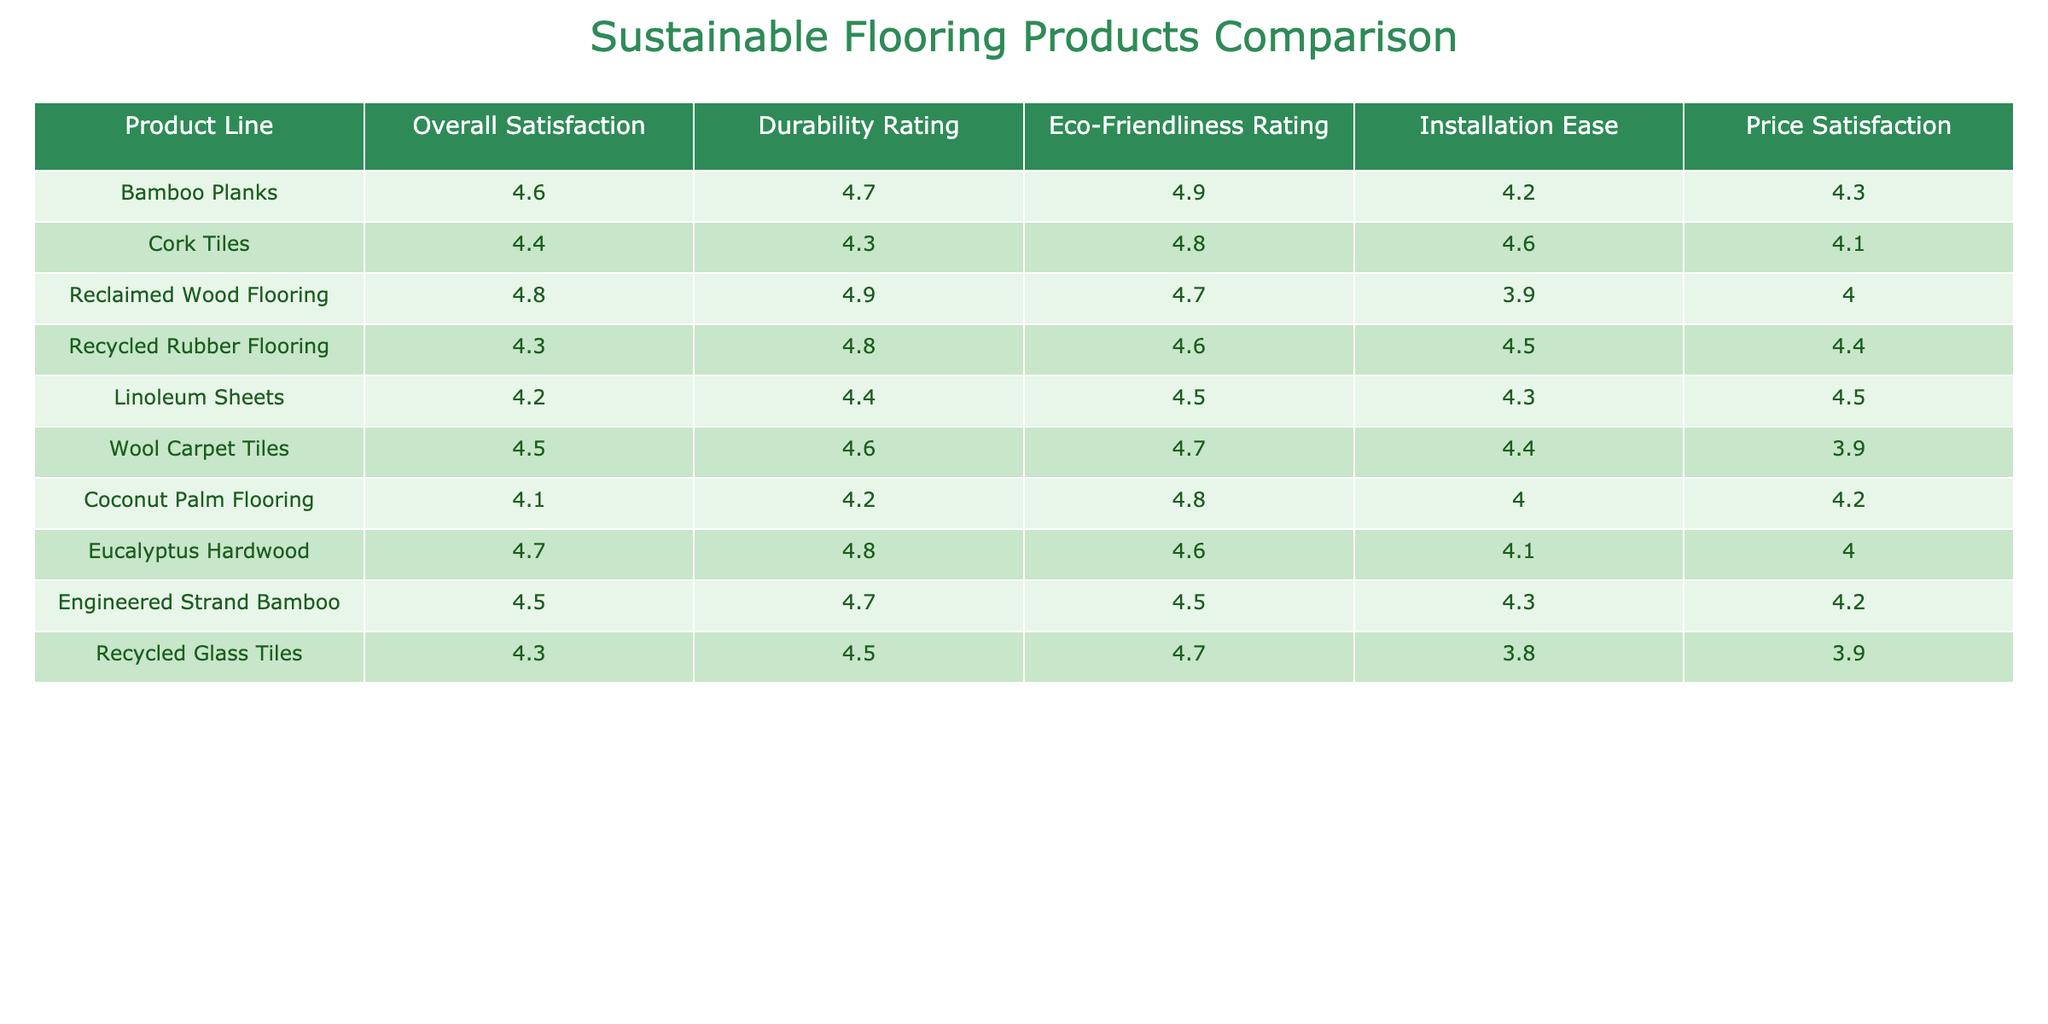What is the overall satisfaction rating for the Reclaimed Wood Flooring? The Reclaimed Wood Flooring has an overall satisfaction rating of 4.8, which can be found in the corresponding cell in the Overall Satisfaction column of the table.
Answer: 4.8 Which product line has the highest durability rating and what is that rating? The product line with the highest durability rating is Reclaimed Wood Flooring, which has a durability rating of 4.9. This can be seen by comparing all durability ratings listed in the table.
Answer: 4.9 Is the Eco-Friendliness Rating for Eucalyptus Hardwood greater than that for Linoleum Sheets? Yes, the Eco-Friendliness Rating for Eucalyptus Hardwood is 4.6, which is greater than the Eco-Friendliness Rating for Linoleum Sheets, which is 4.5. This comparison can be made by directly looking at the respective ratings in the Eco-Friendliness Rating column.
Answer: Yes What is the average price satisfaction rating for Bamboo Planks and Cork Tiles? To find the average price satisfaction rating, we add the price satisfactions of both product lines, which are 4.3 (Bamboo Planks) and 4.1 (Cork Tiles), giving us a total of 8.4. Then dividing by 2, we get an average of 4.2.
Answer: 4.2 Among the product lines, which one has the lowest installation ease rating and what is that rating? The product line with the lowest installation ease rating is Reclaimed Wood Flooring with a rating of 3.9. This is determined by comparing the installation ease ratings of all product lines listed in the table.
Answer: 3.9 Is the Overall Satisfaction for Recycled Glass Tiles greater than the Overall Satisfaction for Wool Carpet Tiles? No, the Overall Satisfaction for Recycled Glass Tiles is 4.3, which is less than the Overall Satisfaction for Wool Carpet Tiles, which is 4.5. This requires looking at and comparing the ratings for both product lines in the Overall Satisfaction column.
Answer: No How does the Eco-Friendliness Rating compare between Engineered Strand Bamboo and Coconut Palm Flooring? Engineered Strand Bamboo has an Eco-Friendliness Rating of 4.5, which is higher than Coconut Palm Flooring with a rating of 4.8. This is determined by comparing the Eco-Friendliness Ratings for both product lines in the respective column of the table.
Answer: Coconut Palm Flooring has a higher rating 